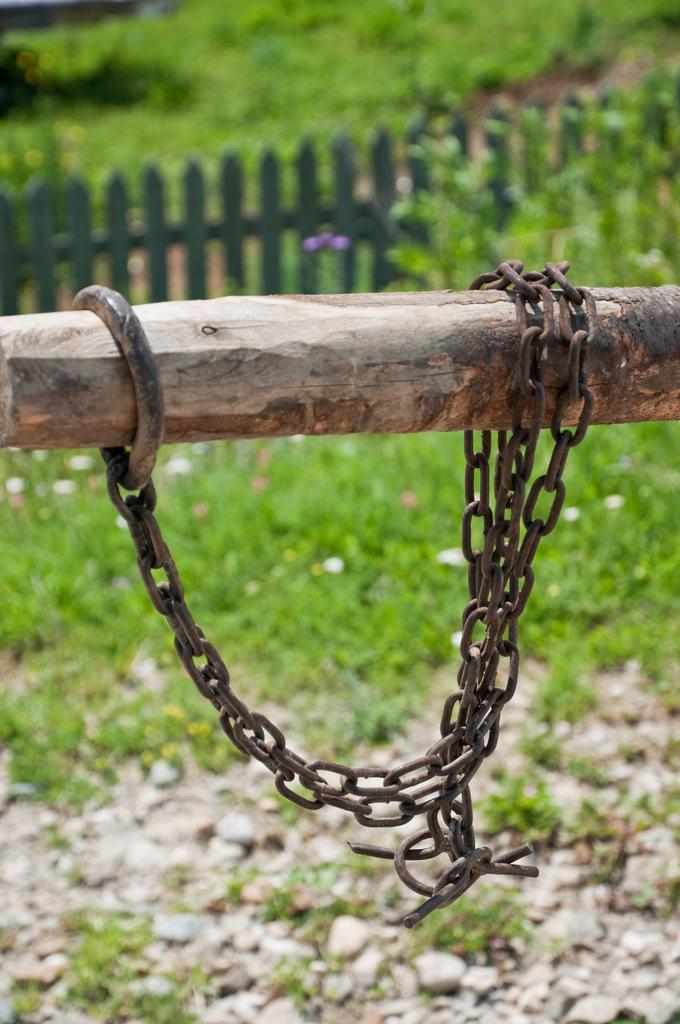What is located in the foreground of the image? There is a pole in the foreground of the image. What is attached to the pole? There is an iron chain on the pole. What can be seen in the background of the image? Plants, grass, and a wooden fence are visible in the background of the image. What type of ground surface is present in the image? There are stones on the ground in the image. What type of bedroom furniture can be seen in the image? There is no bedroom furniture present in the image; it features a pole with an iron chain and a background with plants, grass, and a wooden fence. 